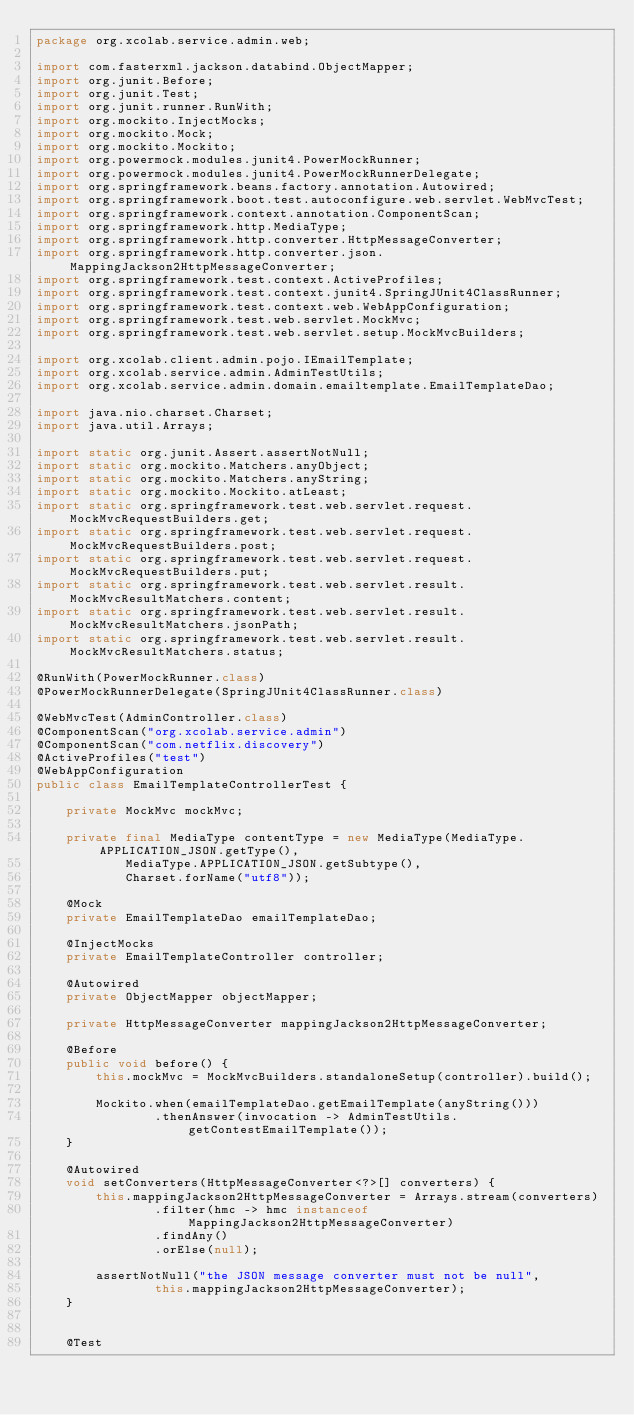<code> <loc_0><loc_0><loc_500><loc_500><_Java_>package org.xcolab.service.admin.web;

import com.fasterxml.jackson.databind.ObjectMapper;
import org.junit.Before;
import org.junit.Test;
import org.junit.runner.RunWith;
import org.mockito.InjectMocks;
import org.mockito.Mock;
import org.mockito.Mockito;
import org.powermock.modules.junit4.PowerMockRunner;
import org.powermock.modules.junit4.PowerMockRunnerDelegate;
import org.springframework.beans.factory.annotation.Autowired;
import org.springframework.boot.test.autoconfigure.web.servlet.WebMvcTest;
import org.springframework.context.annotation.ComponentScan;
import org.springframework.http.MediaType;
import org.springframework.http.converter.HttpMessageConverter;
import org.springframework.http.converter.json.MappingJackson2HttpMessageConverter;
import org.springframework.test.context.ActiveProfiles;
import org.springframework.test.context.junit4.SpringJUnit4ClassRunner;
import org.springframework.test.context.web.WebAppConfiguration;
import org.springframework.test.web.servlet.MockMvc;
import org.springframework.test.web.servlet.setup.MockMvcBuilders;

import org.xcolab.client.admin.pojo.IEmailTemplate;
import org.xcolab.service.admin.AdminTestUtils;
import org.xcolab.service.admin.domain.emailtemplate.EmailTemplateDao;

import java.nio.charset.Charset;
import java.util.Arrays;

import static org.junit.Assert.assertNotNull;
import static org.mockito.Matchers.anyObject;
import static org.mockito.Matchers.anyString;
import static org.mockito.Mockito.atLeast;
import static org.springframework.test.web.servlet.request.MockMvcRequestBuilders.get;
import static org.springframework.test.web.servlet.request.MockMvcRequestBuilders.post;
import static org.springframework.test.web.servlet.request.MockMvcRequestBuilders.put;
import static org.springframework.test.web.servlet.result.MockMvcResultMatchers.content;
import static org.springframework.test.web.servlet.result.MockMvcResultMatchers.jsonPath;
import static org.springframework.test.web.servlet.result.MockMvcResultMatchers.status;

@RunWith(PowerMockRunner.class)
@PowerMockRunnerDelegate(SpringJUnit4ClassRunner.class)

@WebMvcTest(AdminController.class)
@ComponentScan("org.xcolab.service.admin")
@ComponentScan("com.netflix.discovery")
@ActiveProfiles("test")
@WebAppConfiguration
public class EmailTemplateControllerTest {

    private MockMvc mockMvc;

    private final MediaType contentType = new MediaType(MediaType.APPLICATION_JSON.getType(),
            MediaType.APPLICATION_JSON.getSubtype(),
            Charset.forName("utf8"));

    @Mock
    private EmailTemplateDao emailTemplateDao;

    @InjectMocks
    private EmailTemplateController controller;

    @Autowired
    private ObjectMapper objectMapper;

    private HttpMessageConverter mappingJackson2HttpMessageConverter;

    @Before
    public void before() {
        this.mockMvc = MockMvcBuilders.standaloneSetup(controller).build();

        Mockito.when(emailTemplateDao.getEmailTemplate(anyString()))
                .thenAnswer(invocation -> AdminTestUtils.getContestEmailTemplate());
    }

    @Autowired
    void setConverters(HttpMessageConverter<?>[] converters) {
        this.mappingJackson2HttpMessageConverter = Arrays.stream(converters)
                .filter(hmc -> hmc instanceof MappingJackson2HttpMessageConverter)
                .findAny()
                .orElse(null);

        assertNotNull("the JSON message converter must not be null",
                this.mappingJackson2HttpMessageConverter);
    }


    @Test</code> 